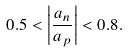<formula> <loc_0><loc_0><loc_500><loc_500>0 . 5 < \left | \frac { a _ { n } } { a _ { p } } \right | < 0 . 8 .</formula> 